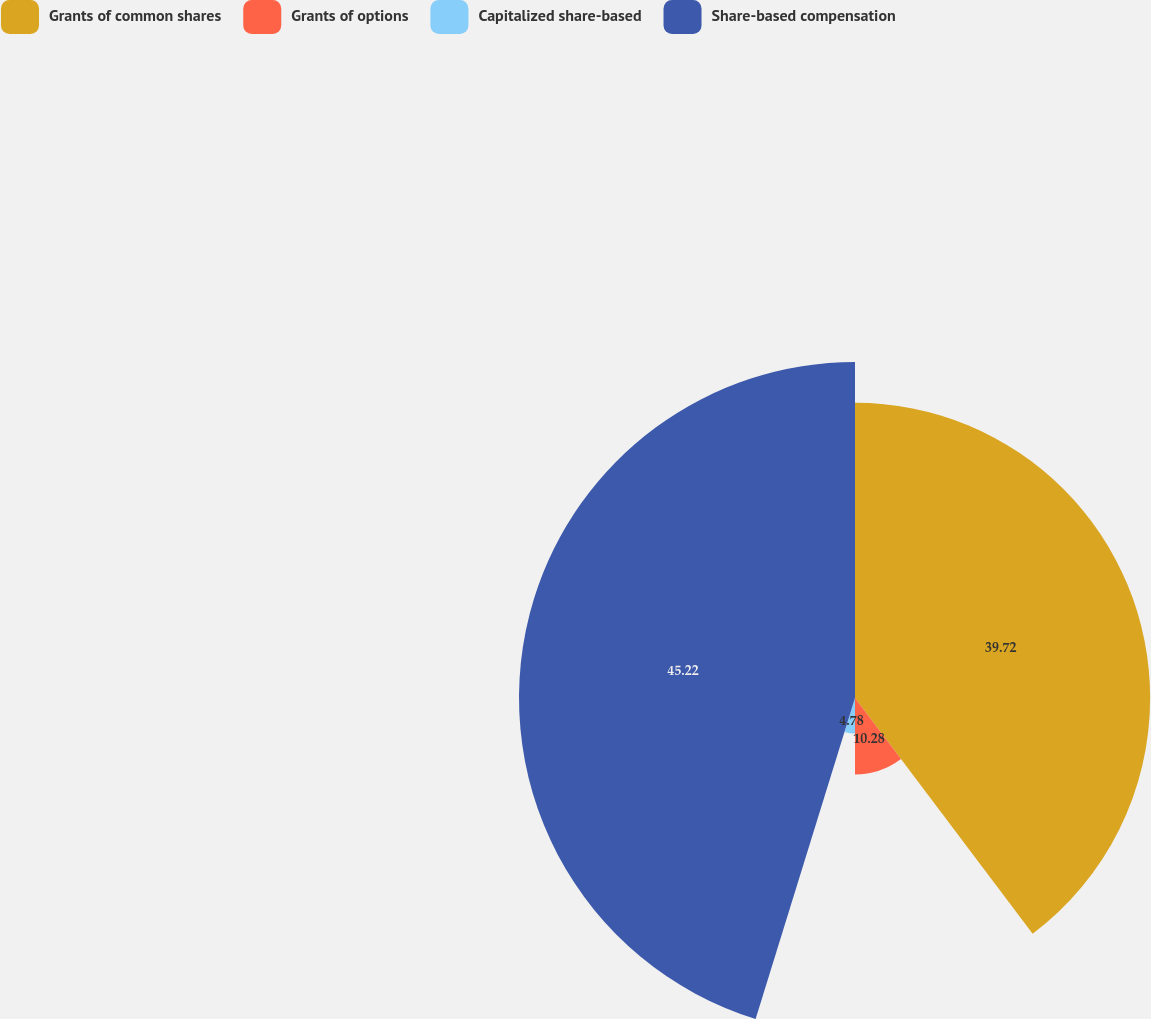<chart> <loc_0><loc_0><loc_500><loc_500><pie_chart><fcel>Grants of common shares<fcel>Grants of options<fcel>Capitalized share-based<fcel>Share-based compensation<nl><fcel>39.72%<fcel>10.28%<fcel>4.78%<fcel>45.22%<nl></chart> 